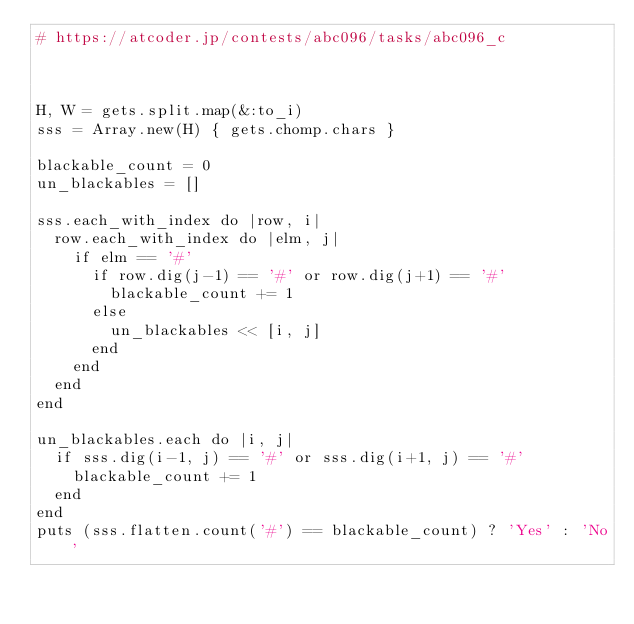<code> <loc_0><loc_0><loc_500><loc_500><_Ruby_># https://atcoder.jp/contests/abc096/tasks/abc096_c



H, W = gets.split.map(&:to_i)
sss = Array.new(H) { gets.chomp.chars }

blackable_count = 0
un_blackables = []

sss.each_with_index do |row, i|
  row.each_with_index do |elm, j|
    if elm == '#'
      if row.dig(j-1) == '#' or row.dig(j+1) == '#'
        blackable_count += 1
      else
        un_blackables << [i, j]
      end
    end
  end
end

un_blackables.each do |i, j|
  if sss.dig(i-1, j) == '#' or sss.dig(i+1, j) == '#'
    blackable_count += 1
  end
end
puts (sss.flatten.count('#') == blackable_count) ? 'Yes' : 'No'
</code> 